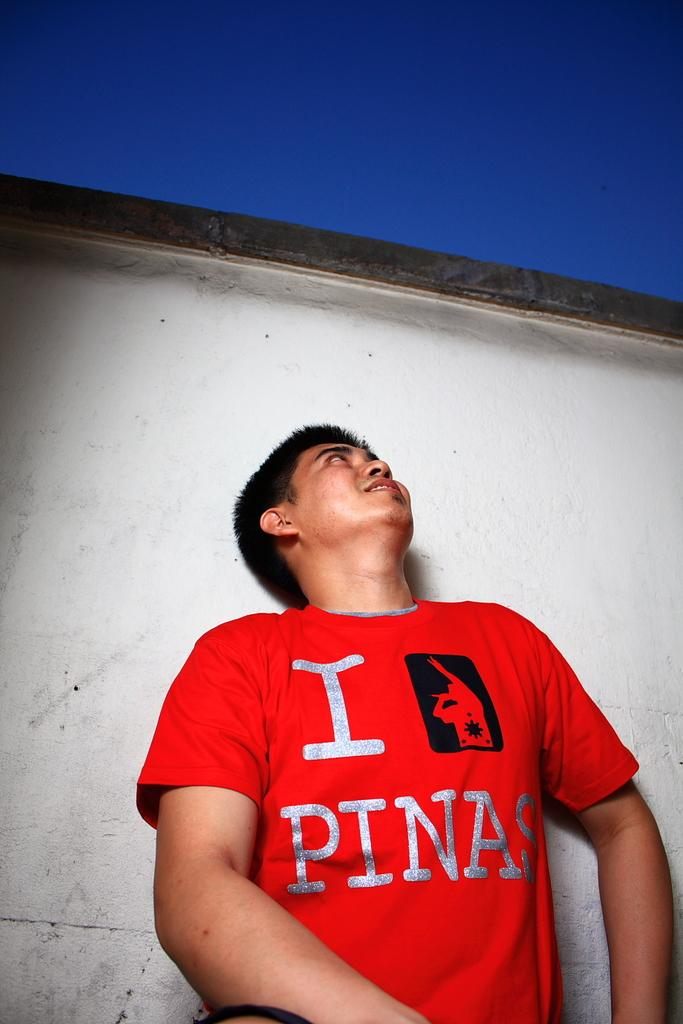Provide a one-sentence caption for the provided image. A man wears a red "I Love Pinas" shirt. 